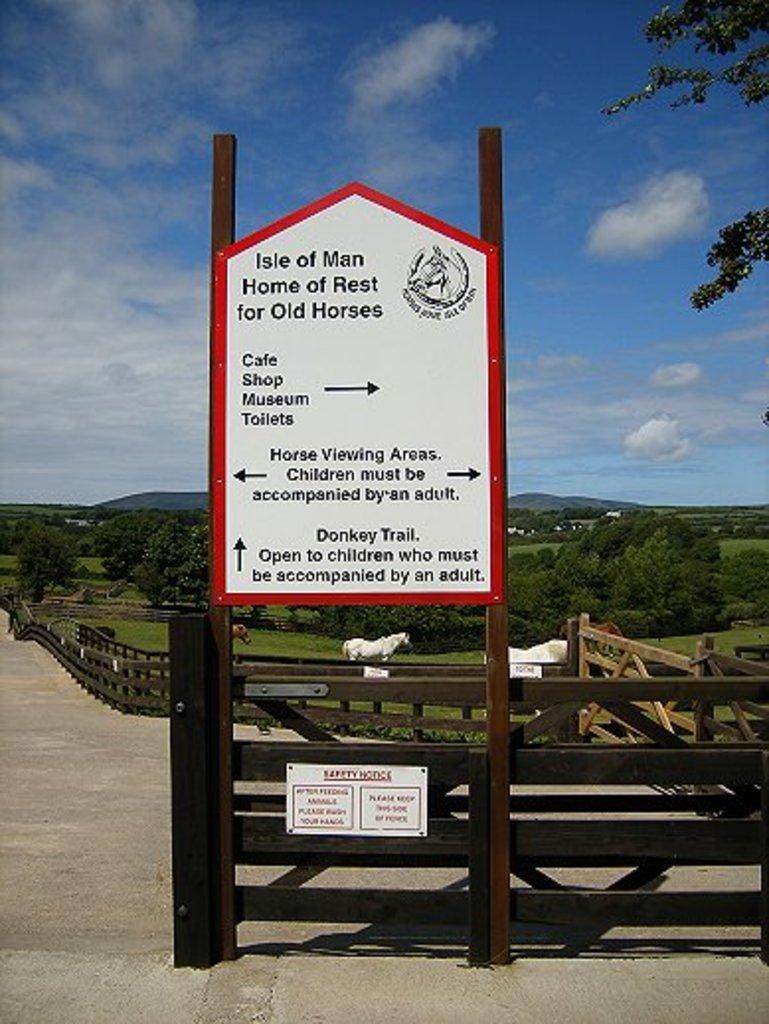In one or two sentences, can you explain what this image depicts? In this image I can see a board , on the board I can see a text and I can see trees,fence and animals visible on the ground in the middle ,at the top I can see the sky. 